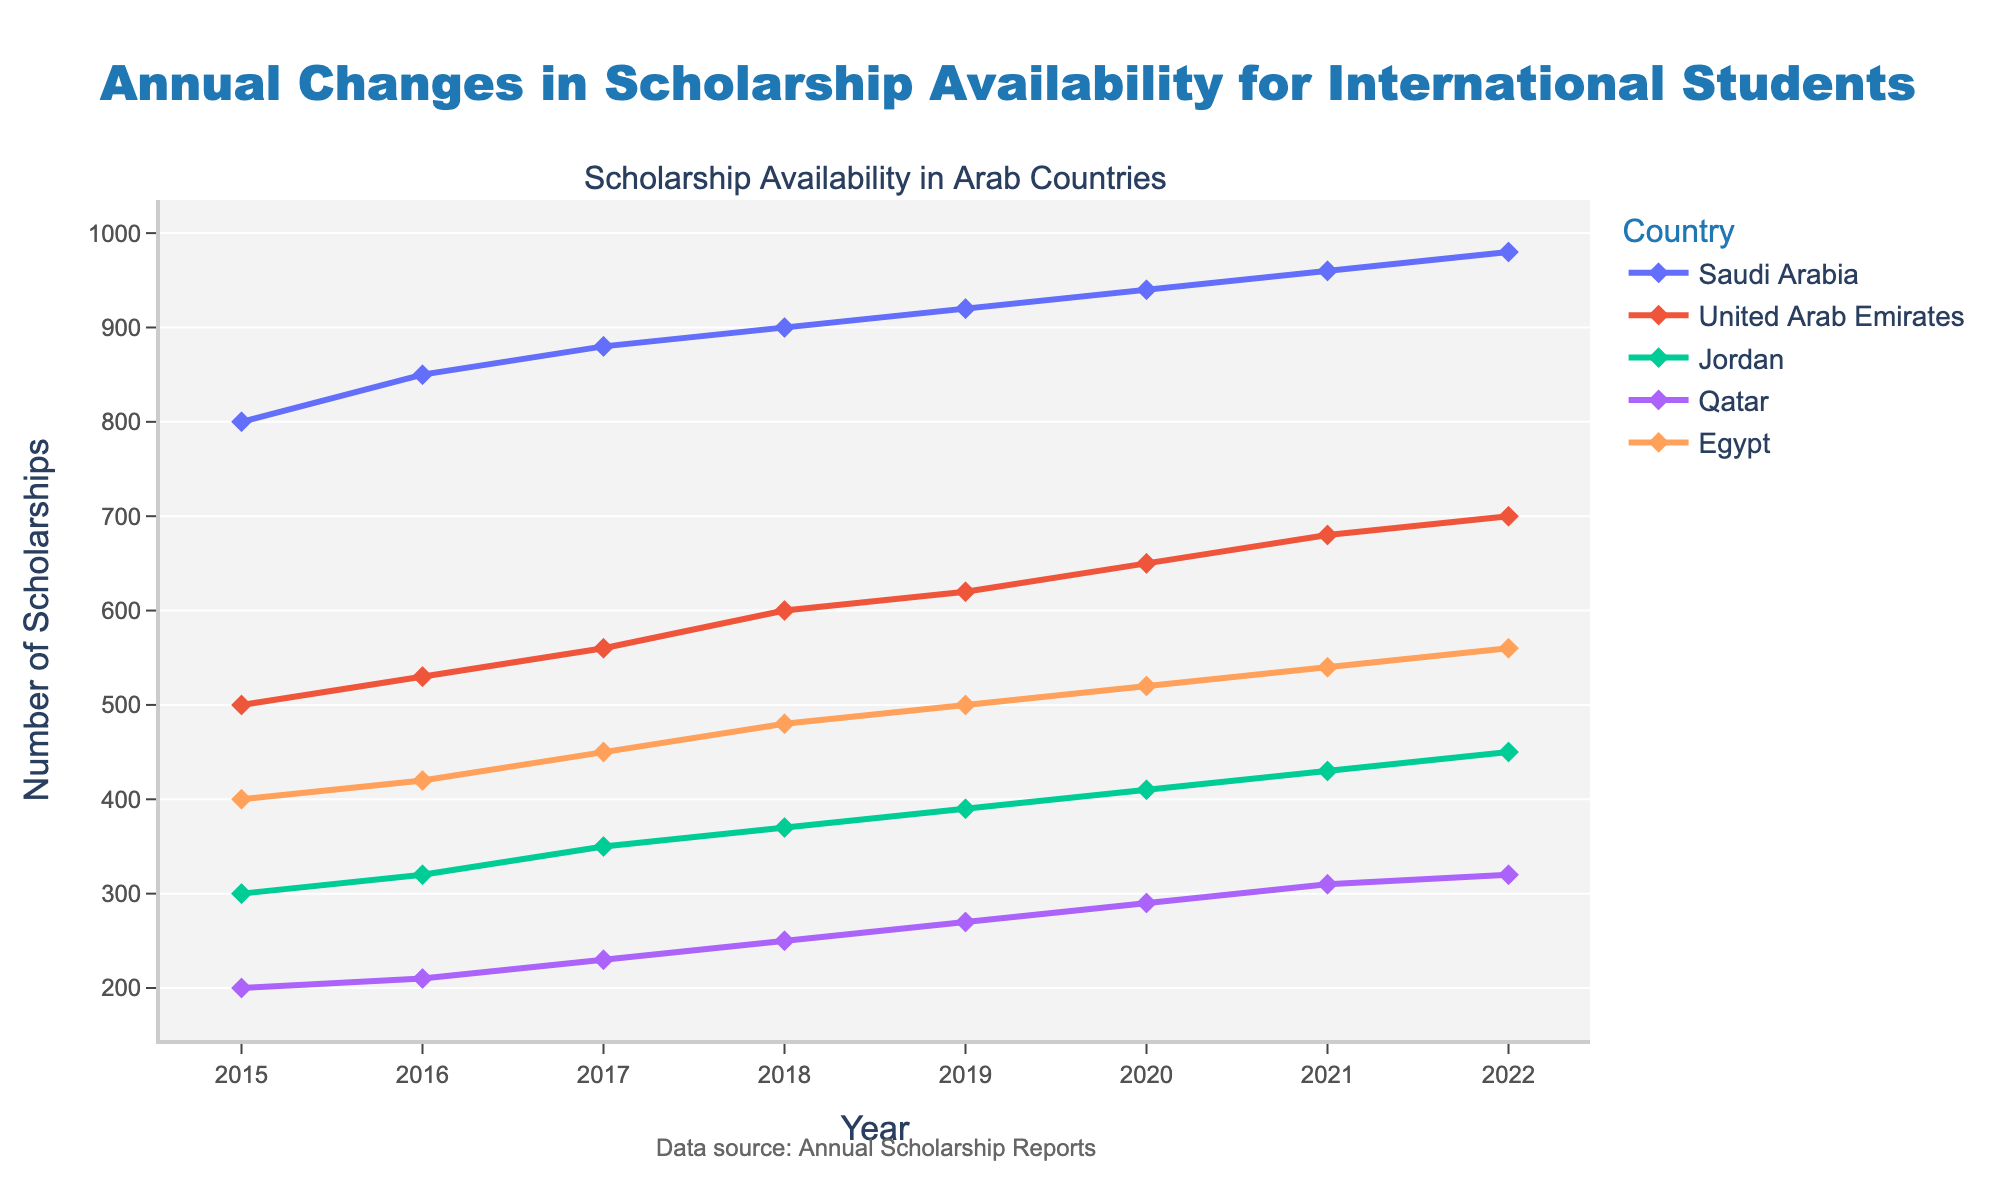How many scholarships were available in Saudi Arabia in 2016? In the figure, find the data point for Saudi Arabia and the year 2016 along the x-axis. The corresponding y-axis value represents the number of scholarships available.
Answer: 850 Which country had the highest number of scholarships available in 2022? Locate the year 2022 on the x-axis, then compare the y-axis values for each country. The highest y-axis value indicates the country with the most scholarships.
Answer: Saudi Arabia What's the trend in the number of scholarships available in Egypt from 2015 to 2022? Follow the line plot for Egypt from 2015 to 2022. Observe whether the line is generally increasing, decreasing, or stable.
Answer: Increasing What's the difference in the number of scholarships available in the United Arab Emirates between 2015 and 2022? Find the y-axis values for the United Arab Emirates in 2015 and 2022, then subtract the smaller value from the larger value.
Answer: 200 Which country experienced the smallest increase in scholarships from 2015 to 2022? Compare the increase in scholarships for each country by subtracting the 2015 value from the 2022 value. The country with the smallest difference has the smallest increase.
Answer: Qatar What's the average number of scholarships available in Jordan from 2015 to 2022? Add the number of scholarships available in Jordan for each year from 2015 to 2022, then divide by the number of years (8).
Answer: 365 Did the number of scholarships in Qatar ever decrease between any two consecutive years? Follow the line plot for Qatar and check if there's any point where the line goes down between two consecutive years.
Answer: No How many total scholarships were available in 2019 across all countries? Sum up the y-axis values for all countries in the year 2019.
Answer: 2700 Which two countries had the closest number of scholarships available in 2020? Compare the y-axis values for all countries in the year 2020 and find the two countries with the smallest difference in their numbers.
Answer: Qatar and Jordan How did the number of scholarships available in Saudi Arabia change from 2017 to 2018? Compare the y-axis values for Saudi Arabia in the years 2017 and 2018. Calculate the difference to see the change.
Answer: Increased by 20 